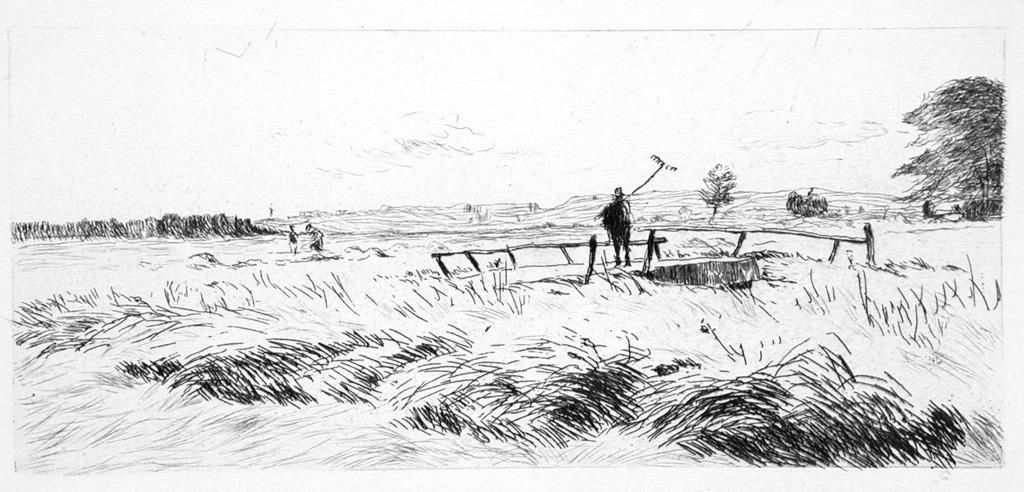What is depicted in the image? There is a drawing in the image. Can you describe the person in the image? There is a person in the image, and they are holding an object. What type of natural elements can be seen in the image? There are trees and plants in the image. What man-made structure is present in the image? There is a fence in the image. What type of skate is the person using in the image? There is no skate present in the image; the person is holding an object, but it is not a skate. What role does the laborer play in the image? There is no laborer present in the image; the person in the image is not identified as a laborer. 